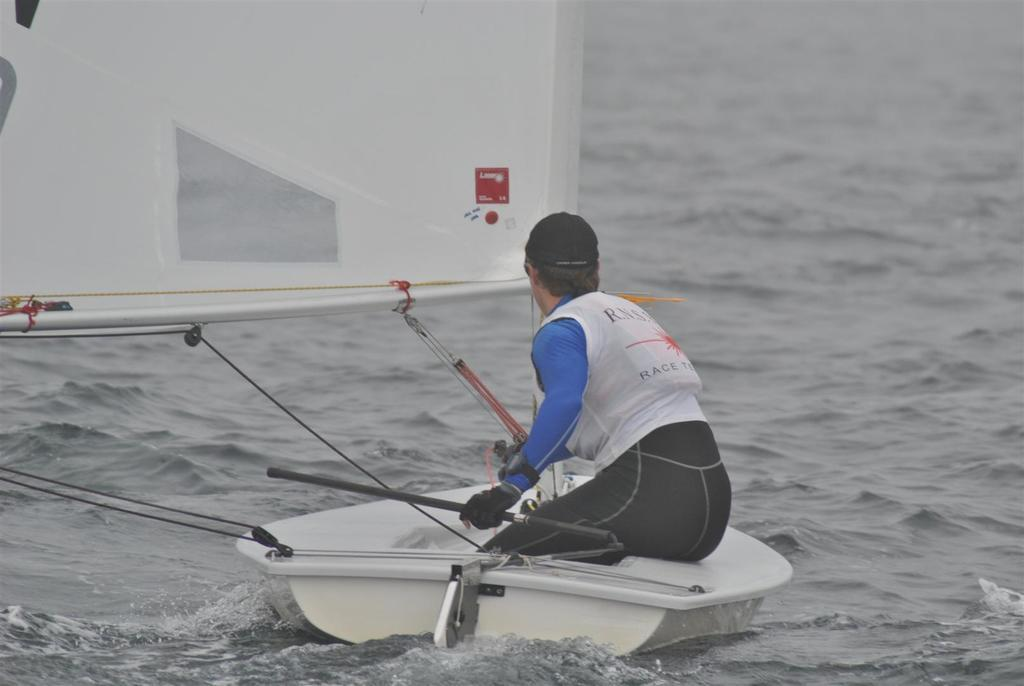What is in the water in the image? There is a boat in the water in the image. What is located inside the boat? There is a man seated in the boat. What type of quartz can be seen in the boat with the man? There is no quartz present in the image; it features a boat in the water with a man seated inside. 